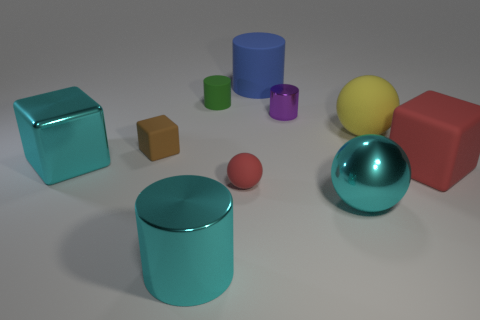Are there any other things that have the same size as the yellow object?
Give a very brief answer. Yes. Are there more tiny green cylinders in front of the big shiny block than red rubber spheres that are right of the big shiny sphere?
Offer a very short reply. No. There is a large block that is on the left side of the purple shiny cylinder; what is it made of?
Make the answer very short. Metal. There is a small purple object; does it have the same shape as the cyan metallic object to the right of the large blue matte thing?
Offer a terse response. No. What number of large cyan metallic spheres are behind the large cyan metallic sphere that is in front of the large cyan cube that is to the left of the small cube?
Provide a short and direct response. 0. What is the color of the other small object that is the same shape as the green object?
Make the answer very short. Purple. Is there any other thing that is the same shape as the small metal thing?
Your response must be concise. Yes. What number of cubes are either big red things or cyan metal things?
Your answer should be compact. 2. There is a large blue thing; what shape is it?
Offer a terse response. Cylinder. There is a metallic ball; are there any large yellow rubber spheres in front of it?
Your answer should be very brief. No. 